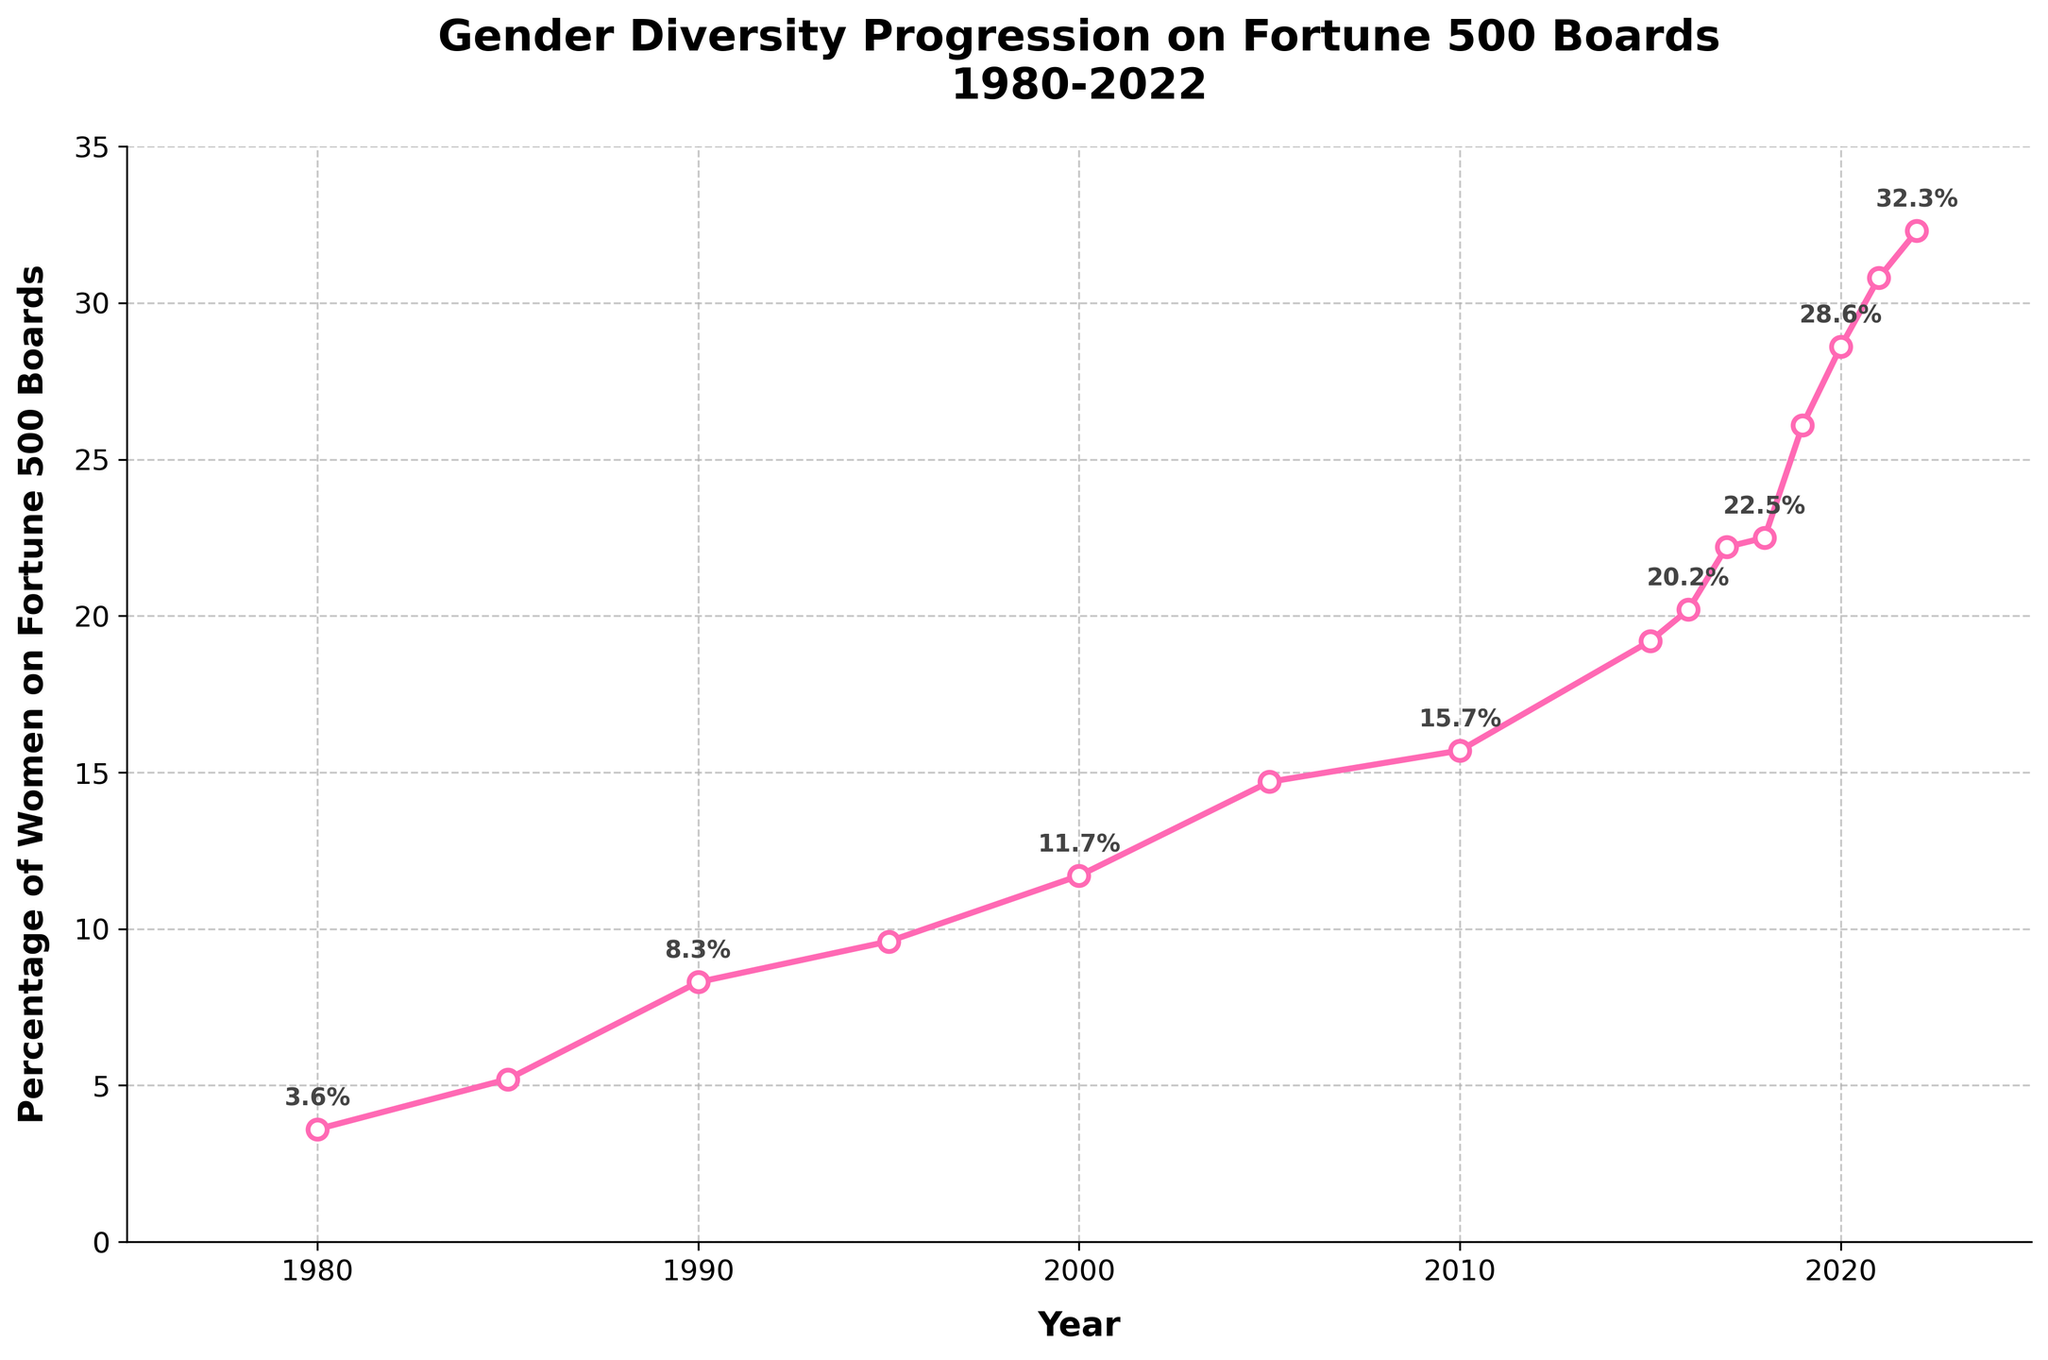What was the approximate percentage increase in women on corporate boards from 1980 to 2022? The percentage of women in 1980 was 3.6%, and in 2022 it was 32.3%. The increase is 32.3% - 3.6% = 28.7%.
Answer: 28.7% Which year between 2010 and 2022 had the largest increase in women's percentage on Fortune 500 boards compared to the previous year? From the figure, there was a notable increase from 2018 (22.5%) to 2019 (26.1%). This is an increase of 3.6%, which is the largest in the given range.
Answer: 2019 How does the trend in the percentage of women on boards from 1980 to 2022 look visually? The trend is shown by a line that starts near 0% in 1980 and rises to over 30% by 2022, indicating a steady increase over time.
Answer: Steady increase Between 2000 and 2010, what was the percentage increase in women on boards? In 2000, the percentage was 11.7%, and in 2010 it was 15.7%. The increase is 15.7% - 11.7% = 4%.
Answer: 4% Is there any year where the percentage of women on corporate boards decreased from the previous year? Comparing the data visually, there are no years where the percentage decreased from the previous year; all years show an increase or remain the same.
Answer: No How many years did it take for the percentage of women on boards to rise from around 10% to over 20%? The percentage was 9.6% in 1995 and reached 20.2% in 2016. It took 2016 - 1995 = 21 years.
Answer: 21 years What is the visual pattern of the line representing the percentage of women over time? The line starts low in 1980, gradually rises with slight fluctuations, and becomes steeper in the later years, especially post-2015.
Answer: Gradual rise with steeper increase post-2015 What is the percentage of women on boards in 2021, and how does it compare to 2010? In 2021, the percentage was 30.8%, and in 2010, it was 15.7%. The difference is 30.8% - 15.7% = 15.1%.
Answer: 30.8%, 15.1% more than 2010 By how much did the percentage of women on boards increase from 1985 to 1990? In 1985, it was 5.2%, and in 1990 it was 8.3%. The increase is 8.3% - 5.2% = 3.1%.
Answer: 3.1% What is the slope of the line between 2017 and 2019, and what does it indicate? The percentage increased from 22.2% in 2017 to 26.1% in 2019. The slope is (26.1% - 22.2%) / (2019 - 2017) = 1.95% per year. It indicates a rapid increase during this period.
Answer: 1.95% per year, rapid increase 